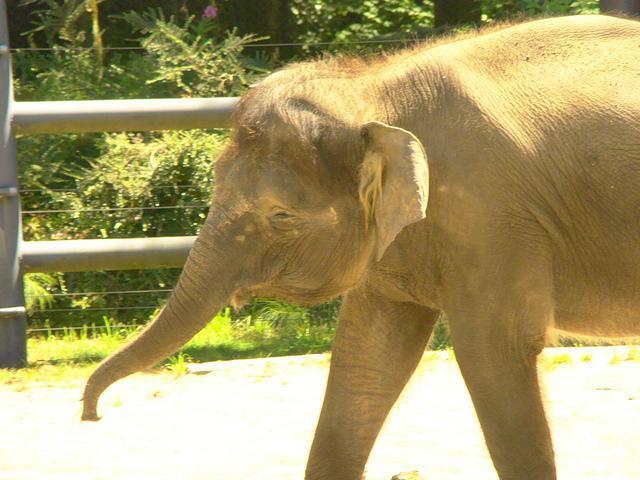How many people have eon green jackets?
Give a very brief answer. 0. 